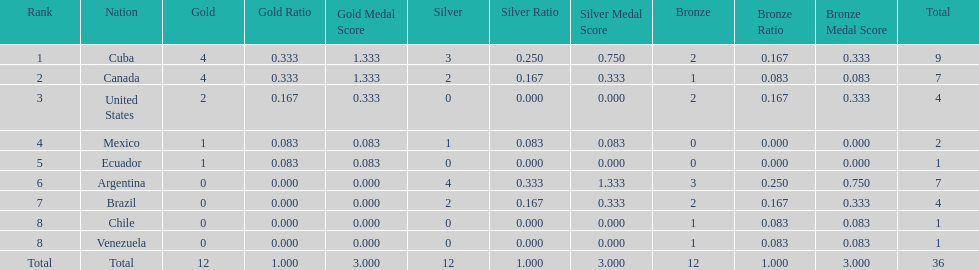Which nations competed in the 2011 pan american games? Cuba, Canada, United States, Mexico, Ecuador, Argentina, Brazil, Chile, Venezuela. Of these nations which ones won gold? Cuba, Canada, United States, Mexico, Ecuador. Which nation of the ones that won gold did not win silver? United States. 